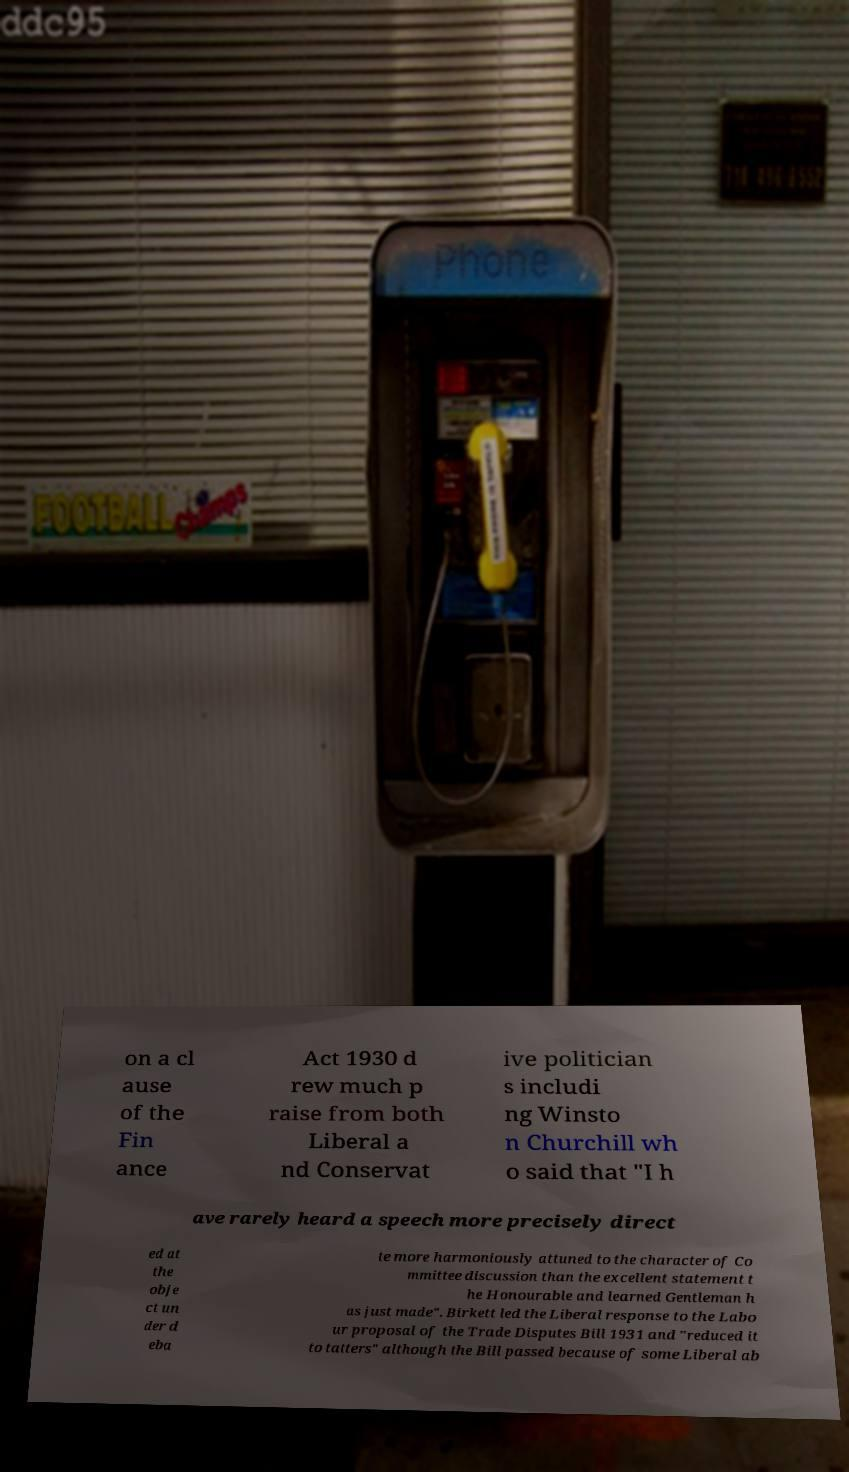I need the written content from this picture converted into text. Can you do that? on a cl ause of the Fin ance Act 1930 d rew much p raise from both Liberal a nd Conservat ive politician s includi ng Winsto n Churchill wh o said that "I h ave rarely heard a speech more precisely direct ed at the obje ct un der d eba te more harmoniously attuned to the character of Co mmittee discussion than the excellent statement t he Honourable and learned Gentleman h as just made". Birkett led the Liberal response to the Labo ur proposal of the Trade Disputes Bill 1931 and "reduced it to tatters" although the Bill passed because of some Liberal ab 